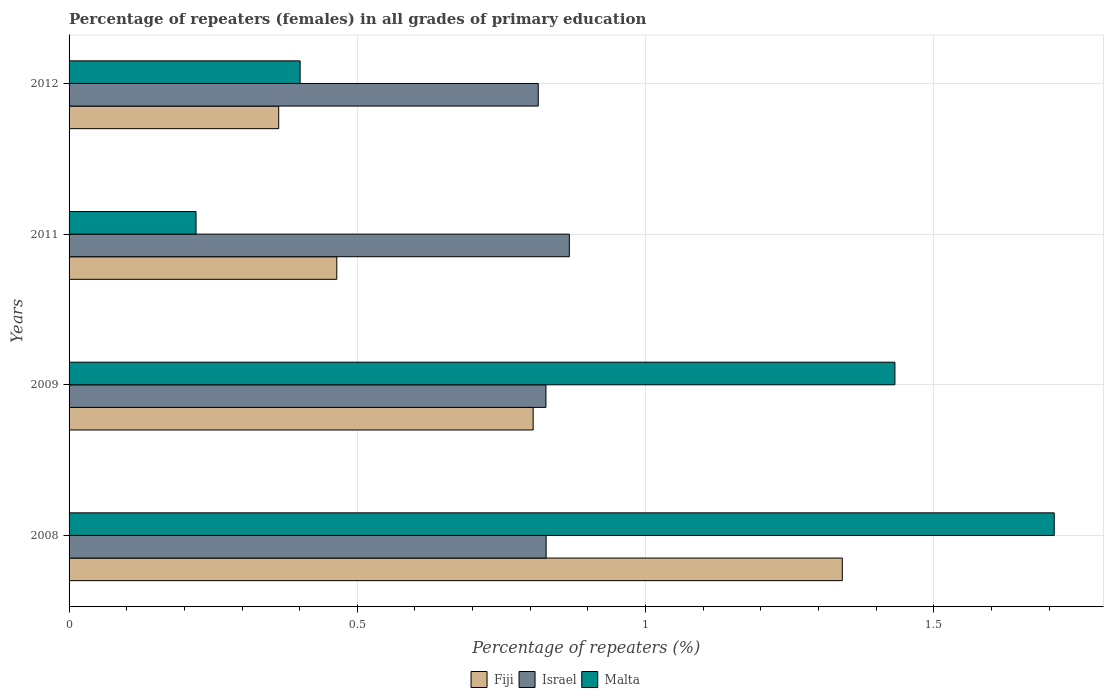How many different coloured bars are there?
Ensure brevity in your answer.  3. How many groups of bars are there?
Offer a terse response. 4. Are the number of bars on each tick of the Y-axis equal?
Provide a short and direct response. Yes. What is the label of the 3rd group of bars from the top?
Ensure brevity in your answer.  2009. In how many cases, is the number of bars for a given year not equal to the number of legend labels?
Your answer should be very brief. 0. What is the percentage of repeaters (females) in Israel in 2008?
Keep it short and to the point. 0.83. Across all years, what is the maximum percentage of repeaters (females) in Malta?
Keep it short and to the point. 1.71. Across all years, what is the minimum percentage of repeaters (females) in Malta?
Your answer should be very brief. 0.22. In which year was the percentage of repeaters (females) in Malta maximum?
Ensure brevity in your answer.  2008. In which year was the percentage of repeaters (females) in Fiji minimum?
Offer a terse response. 2012. What is the total percentage of repeaters (females) in Fiji in the graph?
Provide a short and direct response. 2.97. What is the difference between the percentage of repeaters (females) in Fiji in 2008 and that in 2012?
Your response must be concise. 0.98. What is the difference between the percentage of repeaters (females) in Israel in 2011 and the percentage of repeaters (females) in Malta in 2012?
Your response must be concise. 0.47. What is the average percentage of repeaters (females) in Israel per year?
Your answer should be compact. 0.83. In the year 2012, what is the difference between the percentage of repeaters (females) in Israel and percentage of repeaters (females) in Fiji?
Offer a very short reply. 0.45. In how many years, is the percentage of repeaters (females) in Fiji greater than 1.4 %?
Offer a terse response. 0. What is the ratio of the percentage of repeaters (females) in Israel in 2009 to that in 2011?
Offer a very short reply. 0.95. Is the percentage of repeaters (females) in Malta in 2008 less than that in 2009?
Ensure brevity in your answer.  No. Is the difference between the percentage of repeaters (females) in Israel in 2011 and 2012 greater than the difference between the percentage of repeaters (females) in Fiji in 2011 and 2012?
Offer a terse response. No. What is the difference between the highest and the second highest percentage of repeaters (females) in Israel?
Make the answer very short. 0.04. What is the difference between the highest and the lowest percentage of repeaters (females) in Fiji?
Give a very brief answer. 0.98. In how many years, is the percentage of repeaters (females) in Israel greater than the average percentage of repeaters (females) in Israel taken over all years?
Give a very brief answer. 1. Is the sum of the percentage of repeaters (females) in Malta in 2009 and 2012 greater than the maximum percentage of repeaters (females) in Fiji across all years?
Your answer should be compact. Yes. What does the 3rd bar from the top in 2008 represents?
Provide a short and direct response. Fiji. What does the 1st bar from the bottom in 2012 represents?
Provide a succinct answer. Fiji. How many bars are there?
Your answer should be very brief. 12. Are all the bars in the graph horizontal?
Offer a terse response. Yes. Does the graph contain grids?
Provide a succinct answer. Yes. What is the title of the graph?
Provide a short and direct response. Percentage of repeaters (females) in all grades of primary education. What is the label or title of the X-axis?
Your response must be concise. Percentage of repeaters (%). What is the Percentage of repeaters (%) in Fiji in 2008?
Offer a very short reply. 1.34. What is the Percentage of repeaters (%) of Israel in 2008?
Provide a short and direct response. 0.83. What is the Percentage of repeaters (%) of Malta in 2008?
Give a very brief answer. 1.71. What is the Percentage of repeaters (%) of Fiji in 2009?
Make the answer very short. 0.8. What is the Percentage of repeaters (%) of Israel in 2009?
Your response must be concise. 0.83. What is the Percentage of repeaters (%) in Malta in 2009?
Keep it short and to the point. 1.43. What is the Percentage of repeaters (%) of Fiji in 2011?
Keep it short and to the point. 0.46. What is the Percentage of repeaters (%) in Israel in 2011?
Ensure brevity in your answer.  0.87. What is the Percentage of repeaters (%) in Malta in 2011?
Your answer should be very brief. 0.22. What is the Percentage of repeaters (%) of Fiji in 2012?
Ensure brevity in your answer.  0.36. What is the Percentage of repeaters (%) in Israel in 2012?
Ensure brevity in your answer.  0.81. What is the Percentage of repeaters (%) of Malta in 2012?
Offer a terse response. 0.4. Across all years, what is the maximum Percentage of repeaters (%) in Fiji?
Offer a very short reply. 1.34. Across all years, what is the maximum Percentage of repeaters (%) of Israel?
Your answer should be very brief. 0.87. Across all years, what is the maximum Percentage of repeaters (%) in Malta?
Offer a very short reply. 1.71. Across all years, what is the minimum Percentage of repeaters (%) of Fiji?
Your response must be concise. 0.36. Across all years, what is the minimum Percentage of repeaters (%) of Israel?
Provide a short and direct response. 0.81. Across all years, what is the minimum Percentage of repeaters (%) in Malta?
Offer a terse response. 0.22. What is the total Percentage of repeaters (%) in Fiji in the graph?
Offer a very short reply. 2.97. What is the total Percentage of repeaters (%) in Israel in the graph?
Provide a succinct answer. 3.34. What is the total Percentage of repeaters (%) in Malta in the graph?
Give a very brief answer. 3.76. What is the difference between the Percentage of repeaters (%) of Fiji in 2008 and that in 2009?
Ensure brevity in your answer.  0.54. What is the difference between the Percentage of repeaters (%) of Israel in 2008 and that in 2009?
Your response must be concise. 0. What is the difference between the Percentage of repeaters (%) in Malta in 2008 and that in 2009?
Your response must be concise. 0.28. What is the difference between the Percentage of repeaters (%) of Fiji in 2008 and that in 2011?
Provide a succinct answer. 0.88. What is the difference between the Percentage of repeaters (%) in Israel in 2008 and that in 2011?
Make the answer very short. -0.04. What is the difference between the Percentage of repeaters (%) of Malta in 2008 and that in 2011?
Your answer should be very brief. 1.49. What is the difference between the Percentage of repeaters (%) of Fiji in 2008 and that in 2012?
Offer a very short reply. 0.98. What is the difference between the Percentage of repeaters (%) of Israel in 2008 and that in 2012?
Your answer should be very brief. 0.01. What is the difference between the Percentage of repeaters (%) in Malta in 2008 and that in 2012?
Ensure brevity in your answer.  1.31. What is the difference between the Percentage of repeaters (%) in Fiji in 2009 and that in 2011?
Make the answer very short. 0.34. What is the difference between the Percentage of repeaters (%) in Israel in 2009 and that in 2011?
Ensure brevity in your answer.  -0.04. What is the difference between the Percentage of repeaters (%) of Malta in 2009 and that in 2011?
Provide a short and direct response. 1.21. What is the difference between the Percentage of repeaters (%) in Fiji in 2009 and that in 2012?
Keep it short and to the point. 0.44. What is the difference between the Percentage of repeaters (%) in Israel in 2009 and that in 2012?
Offer a very short reply. 0.01. What is the difference between the Percentage of repeaters (%) in Malta in 2009 and that in 2012?
Keep it short and to the point. 1.03. What is the difference between the Percentage of repeaters (%) in Fiji in 2011 and that in 2012?
Ensure brevity in your answer.  0.1. What is the difference between the Percentage of repeaters (%) of Israel in 2011 and that in 2012?
Your answer should be compact. 0.05. What is the difference between the Percentage of repeaters (%) of Malta in 2011 and that in 2012?
Offer a terse response. -0.18. What is the difference between the Percentage of repeaters (%) in Fiji in 2008 and the Percentage of repeaters (%) in Israel in 2009?
Your answer should be compact. 0.51. What is the difference between the Percentage of repeaters (%) in Fiji in 2008 and the Percentage of repeaters (%) in Malta in 2009?
Offer a very short reply. -0.09. What is the difference between the Percentage of repeaters (%) in Israel in 2008 and the Percentage of repeaters (%) in Malta in 2009?
Offer a very short reply. -0.6. What is the difference between the Percentage of repeaters (%) in Fiji in 2008 and the Percentage of repeaters (%) in Israel in 2011?
Your answer should be very brief. 0.47. What is the difference between the Percentage of repeaters (%) in Fiji in 2008 and the Percentage of repeaters (%) in Malta in 2011?
Make the answer very short. 1.12. What is the difference between the Percentage of repeaters (%) of Israel in 2008 and the Percentage of repeaters (%) of Malta in 2011?
Provide a short and direct response. 0.61. What is the difference between the Percentage of repeaters (%) in Fiji in 2008 and the Percentage of repeaters (%) in Israel in 2012?
Your response must be concise. 0.53. What is the difference between the Percentage of repeaters (%) in Fiji in 2008 and the Percentage of repeaters (%) in Malta in 2012?
Your response must be concise. 0.94. What is the difference between the Percentage of repeaters (%) of Israel in 2008 and the Percentage of repeaters (%) of Malta in 2012?
Your response must be concise. 0.43. What is the difference between the Percentage of repeaters (%) in Fiji in 2009 and the Percentage of repeaters (%) in Israel in 2011?
Give a very brief answer. -0.06. What is the difference between the Percentage of repeaters (%) of Fiji in 2009 and the Percentage of repeaters (%) of Malta in 2011?
Provide a short and direct response. 0.58. What is the difference between the Percentage of repeaters (%) in Israel in 2009 and the Percentage of repeaters (%) in Malta in 2011?
Provide a succinct answer. 0.61. What is the difference between the Percentage of repeaters (%) of Fiji in 2009 and the Percentage of repeaters (%) of Israel in 2012?
Your answer should be compact. -0.01. What is the difference between the Percentage of repeaters (%) in Fiji in 2009 and the Percentage of repeaters (%) in Malta in 2012?
Your answer should be compact. 0.4. What is the difference between the Percentage of repeaters (%) of Israel in 2009 and the Percentage of repeaters (%) of Malta in 2012?
Give a very brief answer. 0.43. What is the difference between the Percentage of repeaters (%) of Fiji in 2011 and the Percentage of repeaters (%) of Israel in 2012?
Give a very brief answer. -0.35. What is the difference between the Percentage of repeaters (%) of Fiji in 2011 and the Percentage of repeaters (%) of Malta in 2012?
Your answer should be very brief. 0.06. What is the difference between the Percentage of repeaters (%) of Israel in 2011 and the Percentage of repeaters (%) of Malta in 2012?
Offer a terse response. 0.47. What is the average Percentage of repeaters (%) of Fiji per year?
Provide a short and direct response. 0.74. What is the average Percentage of repeaters (%) of Israel per year?
Provide a succinct answer. 0.83. What is the average Percentage of repeaters (%) in Malta per year?
Your response must be concise. 0.94. In the year 2008, what is the difference between the Percentage of repeaters (%) in Fiji and Percentage of repeaters (%) in Israel?
Your answer should be compact. 0.51. In the year 2008, what is the difference between the Percentage of repeaters (%) in Fiji and Percentage of repeaters (%) in Malta?
Offer a terse response. -0.37. In the year 2008, what is the difference between the Percentage of repeaters (%) in Israel and Percentage of repeaters (%) in Malta?
Your answer should be very brief. -0.88. In the year 2009, what is the difference between the Percentage of repeaters (%) in Fiji and Percentage of repeaters (%) in Israel?
Keep it short and to the point. -0.02. In the year 2009, what is the difference between the Percentage of repeaters (%) of Fiji and Percentage of repeaters (%) of Malta?
Your answer should be very brief. -0.63. In the year 2009, what is the difference between the Percentage of repeaters (%) of Israel and Percentage of repeaters (%) of Malta?
Your answer should be very brief. -0.61. In the year 2011, what is the difference between the Percentage of repeaters (%) of Fiji and Percentage of repeaters (%) of Israel?
Your response must be concise. -0.4. In the year 2011, what is the difference between the Percentage of repeaters (%) of Fiji and Percentage of repeaters (%) of Malta?
Ensure brevity in your answer.  0.24. In the year 2011, what is the difference between the Percentage of repeaters (%) of Israel and Percentage of repeaters (%) of Malta?
Give a very brief answer. 0.65. In the year 2012, what is the difference between the Percentage of repeaters (%) of Fiji and Percentage of repeaters (%) of Israel?
Offer a terse response. -0.45. In the year 2012, what is the difference between the Percentage of repeaters (%) in Fiji and Percentage of repeaters (%) in Malta?
Offer a terse response. -0.04. In the year 2012, what is the difference between the Percentage of repeaters (%) of Israel and Percentage of repeaters (%) of Malta?
Your response must be concise. 0.41. What is the ratio of the Percentage of repeaters (%) in Fiji in 2008 to that in 2009?
Offer a terse response. 1.67. What is the ratio of the Percentage of repeaters (%) in Malta in 2008 to that in 2009?
Ensure brevity in your answer.  1.19. What is the ratio of the Percentage of repeaters (%) of Fiji in 2008 to that in 2011?
Your response must be concise. 2.89. What is the ratio of the Percentage of repeaters (%) in Israel in 2008 to that in 2011?
Keep it short and to the point. 0.95. What is the ratio of the Percentage of repeaters (%) in Malta in 2008 to that in 2011?
Make the answer very short. 7.76. What is the ratio of the Percentage of repeaters (%) in Fiji in 2008 to that in 2012?
Offer a very short reply. 3.69. What is the ratio of the Percentage of repeaters (%) of Israel in 2008 to that in 2012?
Provide a succinct answer. 1.02. What is the ratio of the Percentage of repeaters (%) of Malta in 2008 to that in 2012?
Provide a succinct answer. 4.26. What is the ratio of the Percentage of repeaters (%) of Fiji in 2009 to that in 2011?
Offer a terse response. 1.73. What is the ratio of the Percentage of repeaters (%) in Israel in 2009 to that in 2011?
Provide a succinct answer. 0.95. What is the ratio of the Percentage of repeaters (%) of Malta in 2009 to that in 2011?
Offer a terse response. 6.5. What is the ratio of the Percentage of repeaters (%) of Fiji in 2009 to that in 2012?
Your response must be concise. 2.21. What is the ratio of the Percentage of repeaters (%) in Israel in 2009 to that in 2012?
Provide a short and direct response. 1.02. What is the ratio of the Percentage of repeaters (%) of Malta in 2009 to that in 2012?
Give a very brief answer. 3.57. What is the ratio of the Percentage of repeaters (%) of Fiji in 2011 to that in 2012?
Your answer should be very brief. 1.28. What is the ratio of the Percentage of repeaters (%) of Israel in 2011 to that in 2012?
Your response must be concise. 1.07. What is the ratio of the Percentage of repeaters (%) in Malta in 2011 to that in 2012?
Offer a very short reply. 0.55. What is the difference between the highest and the second highest Percentage of repeaters (%) in Fiji?
Your answer should be very brief. 0.54. What is the difference between the highest and the second highest Percentage of repeaters (%) of Israel?
Your answer should be compact. 0.04. What is the difference between the highest and the second highest Percentage of repeaters (%) of Malta?
Your answer should be compact. 0.28. What is the difference between the highest and the lowest Percentage of repeaters (%) in Fiji?
Make the answer very short. 0.98. What is the difference between the highest and the lowest Percentage of repeaters (%) of Israel?
Your answer should be compact. 0.05. What is the difference between the highest and the lowest Percentage of repeaters (%) of Malta?
Your answer should be very brief. 1.49. 